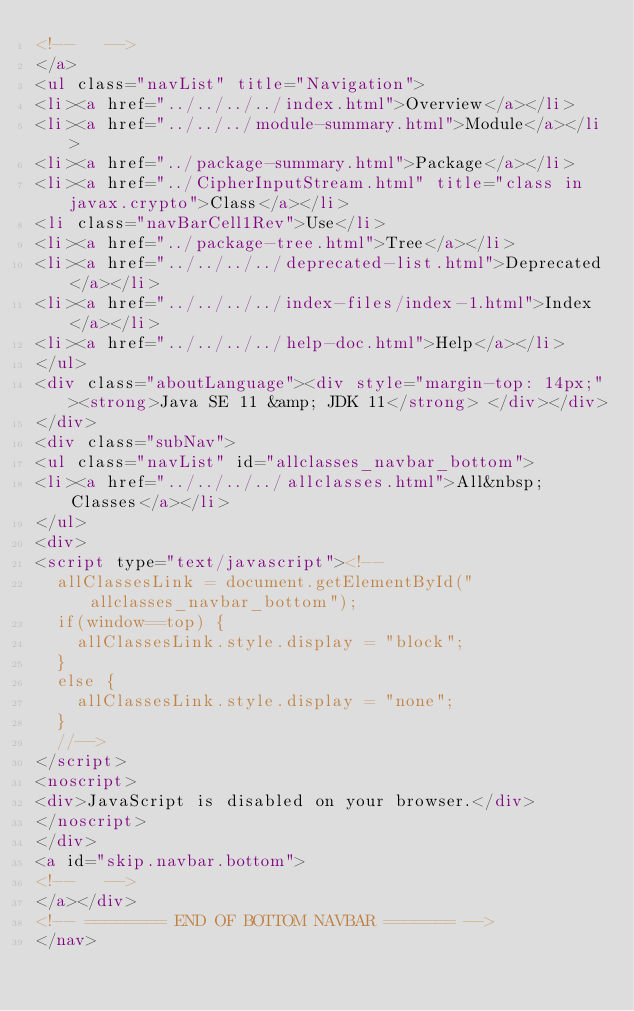Convert code to text. <code><loc_0><loc_0><loc_500><loc_500><_HTML_><!--   -->
</a>
<ul class="navList" title="Navigation">
<li><a href="../../../../index.html">Overview</a></li>
<li><a href="../../../module-summary.html">Module</a></li>
<li><a href="../package-summary.html">Package</a></li>
<li><a href="../CipherInputStream.html" title="class in javax.crypto">Class</a></li>
<li class="navBarCell1Rev">Use</li>
<li><a href="../package-tree.html">Tree</a></li>
<li><a href="../../../../deprecated-list.html">Deprecated</a></li>
<li><a href="../../../../index-files/index-1.html">Index</a></li>
<li><a href="../../../../help-doc.html">Help</a></li>
</ul>
<div class="aboutLanguage"><div style="margin-top: 14px;"><strong>Java SE 11 &amp; JDK 11</strong> </div></div>
</div>
<div class="subNav">
<ul class="navList" id="allclasses_navbar_bottom">
<li><a href="../../../../allclasses.html">All&nbsp;Classes</a></li>
</ul>
<div>
<script type="text/javascript"><!--
  allClassesLink = document.getElementById("allclasses_navbar_bottom");
  if(window==top) {
    allClassesLink.style.display = "block";
  }
  else {
    allClassesLink.style.display = "none";
  }
  //-->
</script>
<noscript>
<div>JavaScript is disabled on your browser.</div>
</noscript>
</div>
<a id="skip.navbar.bottom">
<!--   -->
</a></div>
<!-- ======== END OF BOTTOM NAVBAR ======= -->
</nav></code> 